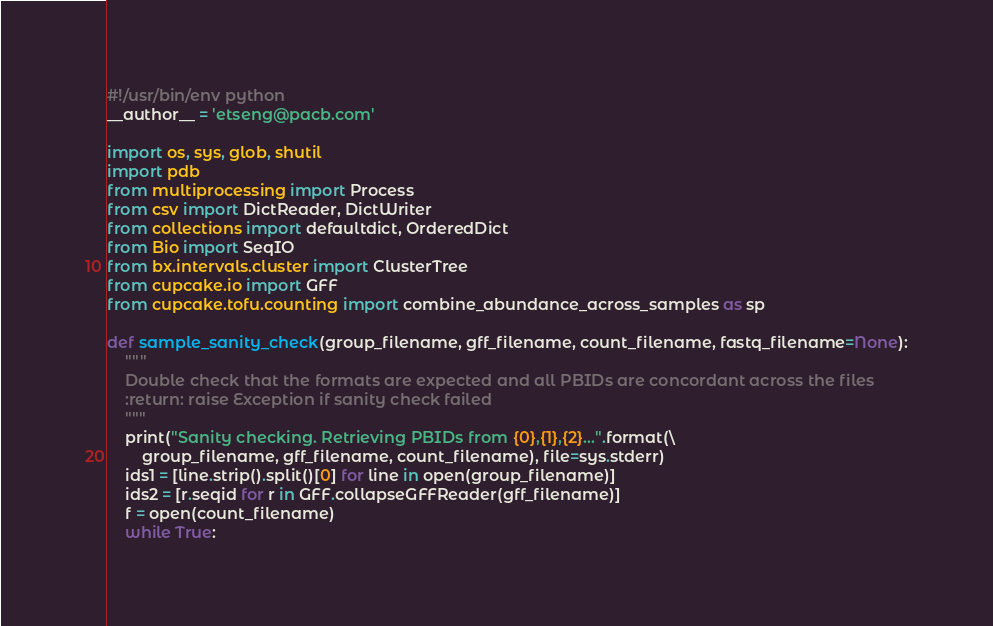Convert code to text. <code><loc_0><loc_0><loc_500><loc_500><_Python_>#!/usr/bin/env python
__author__ = 'etseng@pacb.com'

import os, sys, glob, shutil
import pdb
from multiprocessing import Process
from csv import DictReader, DictWriter
from collections import defaultdict, OrderedDict
from Bio import SeqIO
from bx.intervals.cluster import ClusterTree
from cupcake.io import GFF
from cupcake.tofu.counting import combine_abundance_across_samples as sp

def sample_sanity_check(group_filename, gff_filename, count_filename, fastq_filename=None):
    """
    Double check that the formats are expected and all PBIDs are concordant across the files
    :return: raise Exception if sanity check failed
    """
    print("Sanity checking. Retrieving PBIDs from {0},{1},{2}...".format(\
        group_filename, gff_filename, count_filename), file=sys.stderr)
    ids1 = [line.strip().split()[0] for line in open(group_filename)]
    ids2 = [r.seqid for r in GFF.collapseGFFReader(gff_filename)]
    f = open(count_filename)
    while True:</code> 